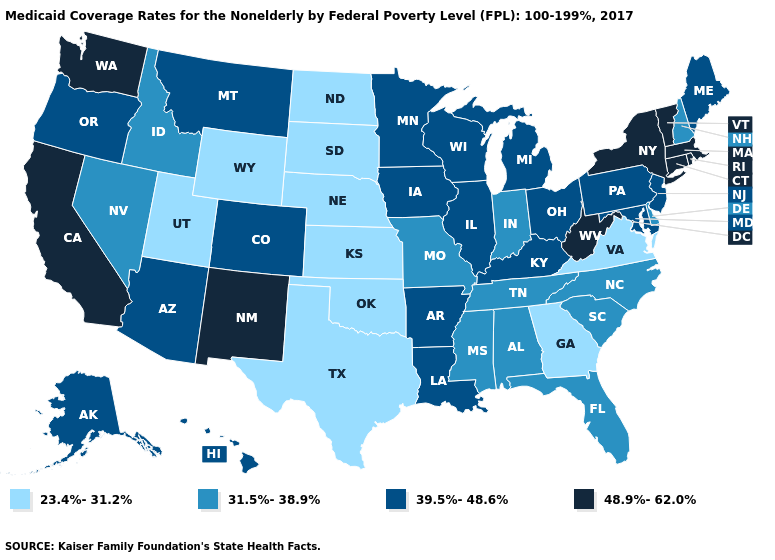Does Washington have the highest value in the USA?
Quick response, please. Yes. Name the states that have a value in the range 39.5%-48.6%?
Be succinct. Alaska, Arizona, Arkansas, Colorado, Hawaii, Illinois, Iowa, Kentucky, Louisiana, Maine, Maryland, Michigan, Minnesota, Montana, New Jersey, Ohio, Oregon, Pennsylvania, Wisconsin. What is the value of Nebraska?
Answer briefly. 23.4%-31.2%. Name the states that have a value in the range 39.5%-48.6%?
Concise answer only. Alaska, Arizona, Arkansas, Colorado, Hawaii, Illinois, Iowa, Kentucky, Louisiana, Maine, Maryland, Michigan, Minnesota, Montana, New Jersey, Ohio, Oregon, Pennsylvania, Wisconsin. Does the map have missing data?
Write a very short answer. No. How many symbols are there in the legend?
Quick response, please. 4. Which states have the lowest value in the USA?
Be succinct. Georgia, Kansas, Nebraska, North Dakota, Oklahoma, South Dakota, Texas, Utah, Virginia, Wyoming. Does Utah have the lowest value in the West?
Short answer required. Yes. Which states have the highest value in the USA?
Quick response, please. California, Connecticut, Massachusetts, New Mexico, New York, Rhode Island, Vermont, Washington, West Virginia. What is the highest value in states that border Maine?
Answer briefly. 31.5%-38.9%. What is the highest value in states that border New Jersey?
Quick response, please. 48.9%-62.0%. What is the lowest value in the USA?
Write a very short answer. 23.4%-31.2%. Does Ohio have a higher value than Utah?
Quick response, please. Yes. Among the states that border Tennessee , does Kentucky have the lowest value?
Answer briefly. No. Which states have the lowest value in the USA?
Write a very short answer. Georgia, Kansas, Nebraska, North Dakota, Oklahoma, South Dakota, Texas, Utah, Virginia, Wyoming. 